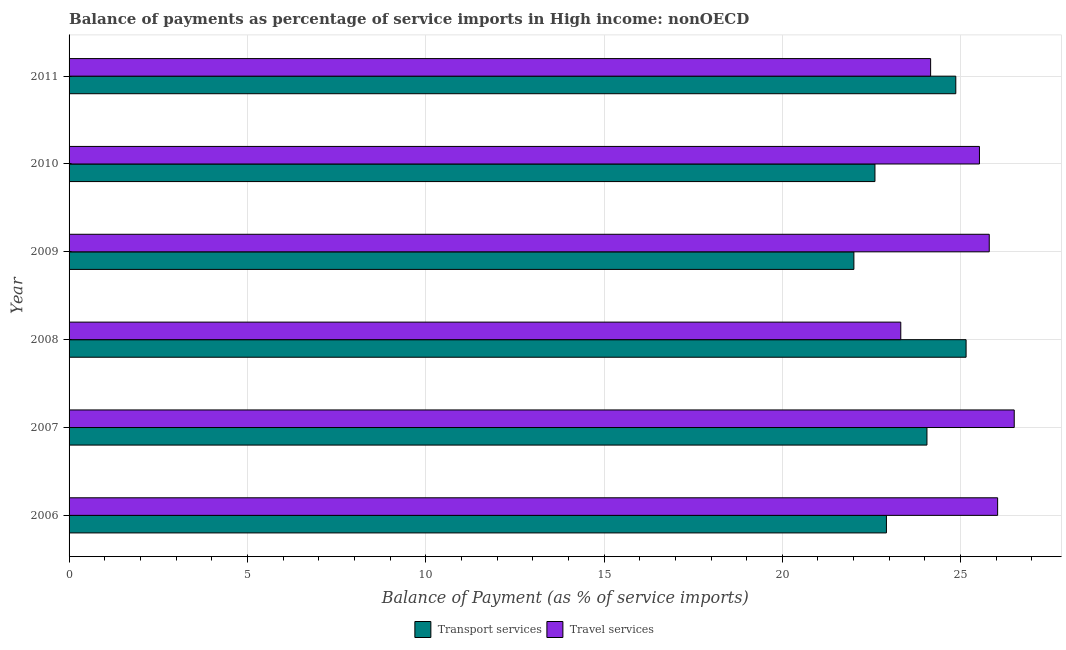How many different coloured bars are there?
Your response must be concise. 2. Are the number of bars per tick equal to the number of legend labels?
Ensure brevity in your answer.  Yes. How many bars are there on the 6th tick from the bottom?
Your answer should be very brief. 2. What is the balance of payments of travel services in 2006?
Keep it short and to the point. 26.04. Across all years, what is the maximum balance of payments of transport services?
Your response must be concise. 25.15. Across all years, what is the minimum balance of payments of travel services?
Keep it short and to the point. 23.32. In which year was the balance of payments of transport services maximum?
Make the answer very short. 2008. In which year was the balance of payments of transport services minimum?
Provide a short and direct response. 2009. What is the total balance of payments of transport services in the graph?
Provide a short and direct response. 141.6. What is the difference between the balance of payments of transport services in 2007 and that in 2008?
Make the answer very short. -1.1. What is the difference between the balance of payments of transport services in 2011 and the balance of payments of travel services in 2007?
Keep it short and to the point. -1.64. What is the average balance of payments of transport services per year?
Your response must be concise. 23.6. In the year 2011, what is the difference between the balance of payments of travel services and balance of payments of transport services?
Your response must be concise. -0.71. In how many years, is the balance of payments of travel services greater than 15 %?
Offer a very short reply. 6. What is the ratio of the balance of payments of travel services in 2008 to that in 2010?
Your answer should be very brief. 0.91. Is the balance of payments of transport services in 2007 less than that in 2010?
Your response must be concise. No. Is the difference between the balance of payments of travel services in 2006 and 2007 greater than the difference between the balance of payments of transport services in 2006 and 2007?
Give a very brief answer. Yes. What is the difference between the highest and the second highest balance of payments of travel services?
Your response must be concise. 0.47. What is the difference between the highest and the lowest balance of payments of transport services?
Your answer should be very brief. 3.15. In how many years, is the balance of payments of travel services greater than the average balance of payments of travel services taken over all years?
Your answer should be compact. 4. Is the sum of the balance of payments of travel services in 2007 and 2010 greater than the maximum balance of payments of transport services across all years?
Offer a terse response. Yes. What does the 2nd bar from the top in 2010 represents?
Ensure brevity in your answer.  Transport services. What does the 2nd bar from the bottom in 2011 represents?
Your answer should be compact. Travel services. How many bars are there?
Provide a short and direct response. 12. Are all the bars in the graph horizontal?
Provide a short and direct response. Yes. What is the difference between two consecutive major ticks on the X-axis?
Ensure brevity in your answer.  5. Are the values on the major ticks of X-axis written in scientific E-notation?
Give a very brief answer. No. Does the graph contain any zero values?
Ensure brevity in your answer.  No. Does the graph contain grids?
Ensure brevity in your answer.  Yes. Where does the legend appear in the graph?
Your answer should be compact. Bottom center. How many legend labels are there?
Make the answer very short. 2. How are the legend labels stacked?
Provide a succinct answer. Horizontal. What is the title of the graph?
Your answer should be very brief. Balance of payments as percentage of service imports in High income: nonOECD. Does "Primary" appear as one of the legend labels in the graph?
Provide a short and direct response. No. What is the label or title of the X-axis?
Provide a short and direct response. Balance of Payment (as % of service imports). What is the Balance of Payment (as % of service imports) of Transport services in 2006?
Your answer should be compact. 22.92. What is the Balance of Payment (as % of service imports) in Travel services in 2006?
Your response must be concise. 26.04. What is the Balance of Payment (as % of service imports) of Transport services in 2007?
Your answer should be very brief. 24.06. What is the Balance of Payment (as % of service imports) of Travel services in 2007?
Your answer should be very brief. 26.5. What is the Balance of Payment (as % of service imports) in Transport services in 2008?
Offer a terse response. 25.15. What is the Balance of Payment (as % of service imports) of Travel services in 2008?
Ensure brevity in your answer.  23.32. What is the Balance of Payment (as % of service imports) of Transport services in 2009?
Ensure brevity in your answer.  22.01. What is the Balance of Payment (as % of service imports) of Travel services in 2009?
Offer a very short reply. 25.8. What is the Balance of Payment (as % of service imports) in Transport services in 2010?
Ensure brevity in your answer.  22.6. What is the Balance of Payment (as % of service imports) in Travel services in 2010?
Your answer should be compact. 25.53. What is the Balance of Payment (as % of service imports) of Transport services in 2011?
Ensure brevity in your answer.  24.86. What is the Balance of Payment (as % of service imports) of Travel services in 2011?
Give a very brief answer. 24.16. Across all years, what is the maximum Balance of Payment (as % of service imports) in Transport services?
Keep it short and to the point. 25.15. Across all years, what is the maximum Balance of Payment (as % of service imports) in Travel services?
Your response must be concise. 26.5. Across all years, what is the minimum Balance of Payment (as % of service imports) in Transport services?
Make the answer very short. 22.01. Across all years, what is the minimum Balance of Payment (as % of service imports) in Travel services?
Make the answer very short. 23.32. What is the total Balance of Payment (as % of service imports) in Transport services in the graph?
Your response must be concise. 141.6. What is the total Balance of Payment (as % of service imports) of Travel services in the graph?
Offer a very short reply. 151.35. What is the difference between the Balance of Payment (as % of service imports) in Transport services in 2006 and that in 2007?
Your response must be concise. -1.14. What is the difference between the Balance of Payment (as % of service imports) in Travel services in 2006 and that in 2007?
Offer a terse response. -0.47. What is the difference between the Balance of Payment (as % of service imports) in Transport services in 2006 and that in 2008?
Give a very brief answer. -2.23. What is the difference between the Balance of Payment (as % of service imports) in Travel services in 2006 and that in 2008?
Provide a short and direct response. 2.72. What is the difference between the Balance of Payment (as % of service imports) in Transport services in 2006 and that in 2009?
Your response must be concise. 0.91. What is the difference between the Balance of Payment (as % of service imports) in Travel services in 2006 and that in 2009?
Ensure brevity in your answer.  0.23. What is the difference between the Balance of Payment (as % of service imports) of Transport services in 2006 and that in 2010?
Offer a terse response. 0.32. What is the difference between the Balance of Payment (as % of service imports) of Travel services in 2006 and that in 2010?
Make the answer very short. 0.51. What is the difference between the Balance of Payment (as % of service imports) in Transport services in 2006 and that in 2011?
Your answer should be very brief. -1.95. What is the difference between the Balance of Payment (as % of service imports) of Travel services in 2006 and that in 2011?
Offer a terse response. 1.88. What is the difference between the Balance of Payment (as % of service imports) in Transport services in 2007 and that in 2008?
Offer a terse response. -1.1. What is the difference between the Balance of Payment (as % of service imports) in Travel services in 2007 and that in 2008?
Your answer should be compact. 3.18. What is the difference between the Balance of Payment (as % of service imports) in Transport services in 2007 and that in 2009?
Offer a very short reply. 2.05. What is the difference between the Balance of Payment (as % of service imports) of Travel services in 2007 and that in 2009?
Your response must be concise. 0.7. What is the difference between the Balance of Payment (as % of service imports) of Transport services in 2007 and that in 2010?
Your response must be concise. 1.46. What is the difference between the Balance of Payment (as % of service imports) of Travel services in 2007 and that in 2010?
Your answer should be very brief. 0.98. What is the difference between the Balance of Payment (as % of service imports) of Transport services in 2007 and that in 2011?
Your response must be concise. -0.81. What is the difference between the Balance of Payment (as % of service imports) of Travel services in 2007 and that in 2011?
Your response must be concise. 2.34. What is the difference between the Balance of Payment (as % of service imports) in Transport services in 2008 and that in 2009?
Your answer should be compact. 3.15. What is the difference between the Balance of Payment (as % of service imports) of Travel services in 2008 and that in 2009?
Make the answer very short. -2.48. What is the difference between the Balance of Payment (as % of service imports) of Transport services in 2008 and that in 2010?
Provide a succinct answer. 2.56. What is the difference between the Balance of Payment (as % of service imports) of Travel services in 2008 and that in 2010?
Keep it short and to the point. -2.21. What is the difference between the Balance of Payment (as % of service imports) in Transport services in 2008 and that in 2011?
Ensure brevity in your answer.  0.29. What is the difference between the Balance of Payment (as % of service imports) in Travel services in 2008 and that in 2011?
Offer a terse response. -0.84. What is the difference between the Balance of Payment (as % of service imports) in Transport services in 2009 and that in 2010?
Offer a terse response. -0.59. What is the difference between the Balance of Payment (as % of service imports) in Travel services in 2009 and that in 2010?
Keep it short and to the point. 0.27. What is the difference between the Balance of Payment (as % of service imports) of Transport services in 2009 and that in 2011?
Your response must be concise. -2.86. What is the difference between the Balance of Payment (as % of service imports) in Travel services in 2009 and that in 2011?
Ensure brevity in your answer.  1.64. What is the difference between the Balance of Payment (as % of service imports) of Transport services in 2010 and that in 2011?
Ensure brevity in your answer.  -2.27. What is the difference between the Balance of Payment (as % of service imports) of Travel services in 2010 and that in 2011?
Provide a succinct answer. 1.37. What is the difference between the Balance of Payment (as % of service imports) of Transport services in 2006 and the Balance of Payment (as % of service imports) of Travel services in 2007?
Your answer should be compact. -3.58. What is the difference between the Balance of Payment (as % of service imports) in Transport services in 2006 and the Balance of Payment (as % of service imports) in Travel services in 2008?
Make the answer very short. -0.4. What is the difference between the Balance of Payment (as % of service imports) of Transport services in 2006 and the Balance of Payment (as % of service imports) of Travel services in 2009?
Provide a short and direct response. -2.88. What is the difference between the Balance of Payment (as % of service imports) in Transport services in 2006 and the Balance of Payment (as % of service imports) in Travel services in 2010?
Provide a short and direct response. -2.61. What is the difference between the Balance of Payment (as % of service imports) in Transport services in 2006 and the Balance of Payment (as % of service imports) in Travel services in 2011?
Provide a succinct answer. -1.24. What is the difference between the Balance of Payment (as % of service imports) in Transport services in 2007 and the Balance of Payment (as % of service imports) in Travel services in 2008?
Offer a very short reply. 0.73. What is the difference between the Balance of Payment (as % of service imports) of Transport services in 2007 and the Balance of Payment (as % of service imports) of Travel services in 2009?
Your answer should be very brief. -1.75. What is the difference between the Balance of Payment (as % of service imports) of Transport services in 2007 and the Balance of Payment (as % of service imports) of Travel services in 2010?
Ensure brevity in your answer.  -1.47. What is the difference between the Balance of Payment (as % of service imports) of Transport services in 2007 and the Balance of Payment (as % of service imports) of Travel services in 2011?
Give a very brief answer. -0.1. What is the difference between the Balance of Payment (as % of service imports) of Transport services in 2008 and the Balance of Payment (as % of service imports) of Travel services in 2009?
Your answer should be very brief. -0.65. What is the difference between the Balance of Payment (as % of service imports) in Transport services in 2008 and the Balance of Payment (as % of service imports) in Travel services in 2010?
Provide a short and direct response. -0.37. What is the difference between the Balance of Payment (as % of service imports) in Transport services in 2008 and the Balance of Payment (as % of service imports) in Travel services in 2011?
Make the answer very short. 0.99. What is the difference between the Balance of Payment (as % of service imports) in Transport services in 2009 and the Balance of Payment (as % of service imports) in Travel services in 2010?
Give a very brief answer. -3.52. What is the difference between the Balance of Payment (as % of service imports) in Transport services in 2009 and the Balance of Payment (as % of service imports) in Travel services in 2011?
Your answer should be very brief. -2.15. What is the difference between the Balance of Payment (as % of service imports) of Transport services in 2010 and the Balance of Payment (as % of service imports) of Travel services in 2011?
Keep it short and to the point. -1.56. What is the average Balance of Payment (as % of service imports) of Transport services per year?
Your answer should be very brief. 23.6. What is the average Balance of Payment (as % of service imports) in Travel services per year?
Your answer should be compact. 25.23. In the year 2006, what is the difference between the Balance of Payment (as % of service imports) of Transport services and Balance of Payment (as % of service imports) of Travel services?
Give a very brief answer. -3.12. In the year 2007, what is the difference between the Balance of Payment (as % of service imports) of Transport services and Balance of Payment (as % of service imports) of Travel services?
Provide a succinct answer. -2.45. In the year 2008, what is the difference between the Balance of Payment (as % of service imports) in Transport services and Balance of Payment (as % of service imports) in Travel services?
Keep it short and to the point. 1.83. In the year 2009, what is the difference between the Balance of Payment (as % of service imports) in Transport services and Balance of Payment (as % of service imports) in Travel services?
Offer a terse response. -3.8. In the year 2010, what is the difference between the Balance of Payment (as % of service imports) in Transport services and Balance of Payment (as % of service imports) in Travel services?
Keep it short and to the point. -2.93. In the year 2011, what is the difference between the Balance of Payment (as % of service imports) of Transport services and Balance of Payment (as % of service imports) of Travel services?
Ensure brevity in your answer.  0.71. What is the ratio of the Balance of Payment (as % of service imports) of Transport services in 2006 to that in 2007?
Your response must be concise. 0.95. What is the ratio of the Balance of Payment (as % of service imports) in Travel services in 2006 to that in 2007?
Make the answer very short. 0.98. What is the ratio of the Balance of Payment (as % of service imports) in Transport services in 2006 to that in 2008?
Make the answer very short. 0.91. What is the ratio of the Balance of Payment (as % of service imports) in Travel services in 2006 to that in 2008?
Give a very brief answer. 1.12. What is the ratio of the Balance of Payment (as % of service imports) in Transport services in 2006 to that in 2009?
Provide a succinct answer. 1.04. What is the ratio of the Balance of Payment (as % of service imports) in Travel services in 2006 to that in 2009?
Your answer should be compact. 1.01. What is the ratio of the Balance of Payment (as % of service imports) of Transport services in 2006 to that in 2010?
Provide a short and direct response. 1.01. What is the ratio of the Balance of Payment (as % of service imports) in Travel services in 2006 to that in 2010?
Offer a terse response. 1.02. What is the ratio of the Balance of Payment (as % of service imports) of Transport services in 2006 to that in 2011?
Your answer should be compact. 0.92. What is the ratio of the Balance of Payment (as % of service imports) of Travel services in 2006 to that in 2011?
Offer a very short reply. 1.08. What is the ratio of the Balance of Payment (as % of service imports) in Transport services in 2007 to that in 2008?
Your answer should be compact. 0.96. What is the ratio of the Balance of Payment (as % of service imports) of Travel services in 2007 to that in 2008?
Your answer should be very brief. 1.14. What is the ratio of the Balance of Payment (as % of service imports) in Transport services in 2007 to that in 2009?
Your response must be concise. 1.09. What is the ratio of the Balance of Payment (as % of service imports) of Travel services in 2007 to that in 2009?
Offer a terse response. 1.03. What is the ratio of the Balance of Payment (as % of service imports) in Transport services in 2007 to that in 2010?
Make the answer very short. 1.06. What is the ratio of the Balance of Payment (as % of service imports) in Travel services in 2007 to that in 2010?
Offer a very short reply. 1.04. What is the ratio of the Balance of Payment (as % of service imports) in Transport services in 2007 to that in 2011?
Your response must be concise. 0.97. What is the ratio of the Balance of Payment (as % of service imports) of Travel services in 2007 to that in 2011?
Ensure brevity in your answer.  1.1. What is the ratio of the Balance of Payment (as % of service imports) of Transport services in 2008 to that in 2009?
Keep it short and to the point. 1.14. What is the ratio of the Balance of Payment (as % of service imports) of Travel services in 2008 to that in 2009?
Make the answer very short. 0.9. What is the ratio of the Balance of Payment (as % of service imports) of Transport services in 2008 to that in 2010?
Ensure brevity in your answer.  1.11. What is the ratio of the Balance of Payment (as % of service imports) in Travel services in 2008 to that in 2010?
Offer a very short reply. 0.91. What is the ratio of the Balance of Payment (as % of service imports) of Transport services in 2008 to that in 2011?
Provide a short and direct response. 1.01. What is the ratio of the Balance of Payment (as % of service imports) of Travel services in 2008 to that in 2011?
Provide a succinct answer. 0.97. What is the ratio of the Balance of Payment (as % of service imports) in Transport services in 2009 to that in 2010?
Make the answer very short. 0.97. What is the ratio of the Balance of Payment (as % of service imports) in Travel services in 2009 to that in 2010?
Provide a succinct answer. 1.01. What is the ratio of the Balance of Payment (as % of service imports) of Transport services in 2009 to that in 2011?
Make the answer very short. 0.89. What is the ratio of the Balance of Payment (as % of service imports) in Travel services in 2009 to that in 2011?
Your response must be concise. 1.07. What is the ratio of the Balance of Payment (as % of service imports) of Transport services in 2010 to that in 2011?
Offer a very short reply. 0.91. What is the ratio of the Balance of Payment (as % of service imports) in Travel services in 2010 to that in 2011?
Offer a very short reply. 1.06. What is the difference between the highest and the second highest Balance of Payment (as % of service imports) of Transport services?
Offer a terse response. 0.29. What is the difference between the highest and the second highest Balance of Payment (as % of service imports) in Travel services?
Ensure brevity in your answer.  0.47. What is the difference between the highest and the lowest Balance of Payment (as % of service imports) of Transport services?
Ensure brevity in your answer.  3.15. What is the difference between the highest and the lowest Balance of Payment (as % of service imports) of Travel services?
Offer a very short reply. 3.18. 